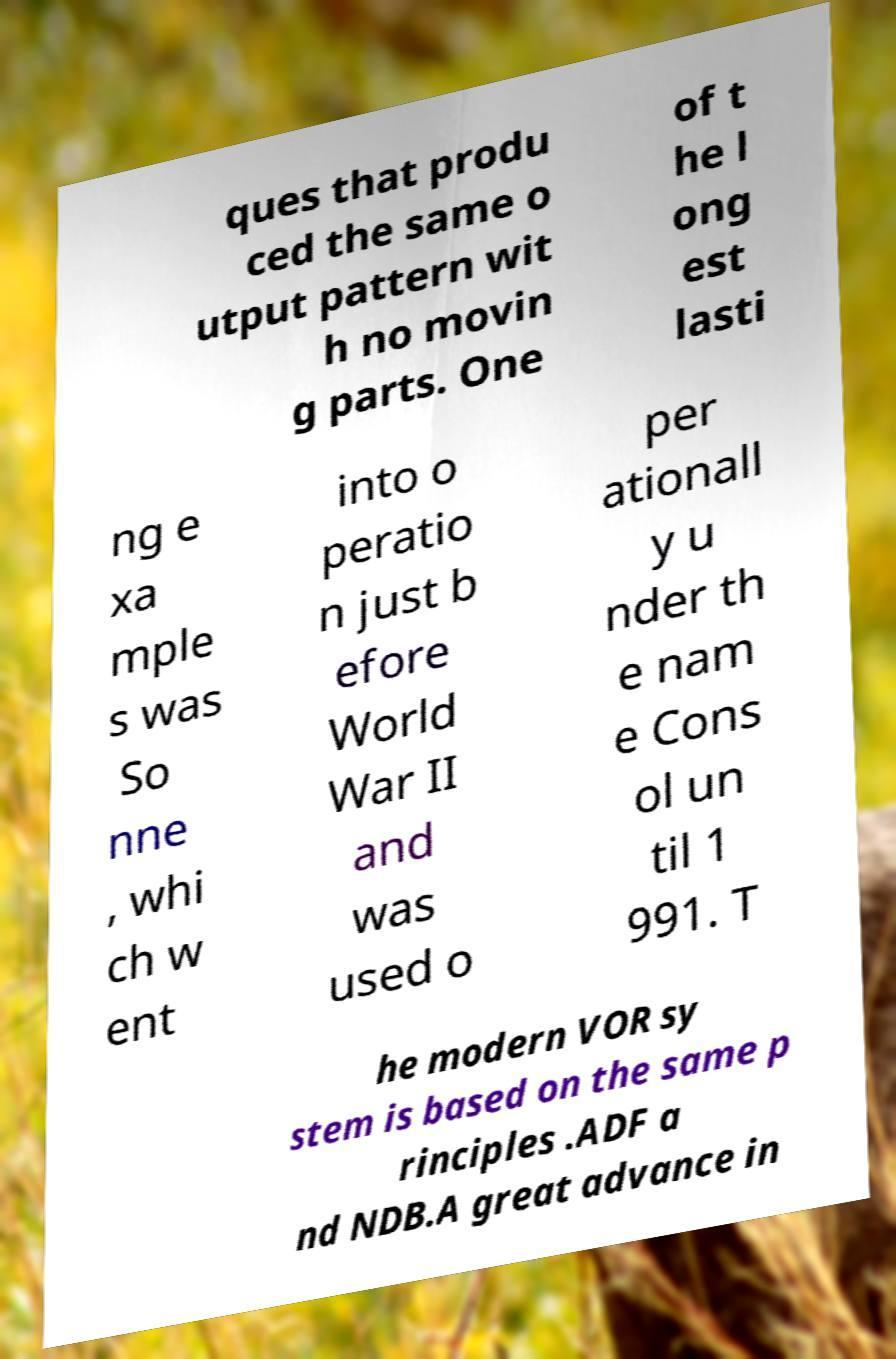What messages or text are displayed in this image? I need them in a readable, typed format. ques that produ ced the same o utput pattern wit h no movin g parts. One of t he l ong est lasti ng e xa mple s was So nne , whi ch w ent into o peratio n just b efore World War II and was used o per ationall y u nder th e nam e Cons ol un til 1 991. T he modern VOR sy stem is based on the same p rinciples .ADF a nd NDB.A great advance in 